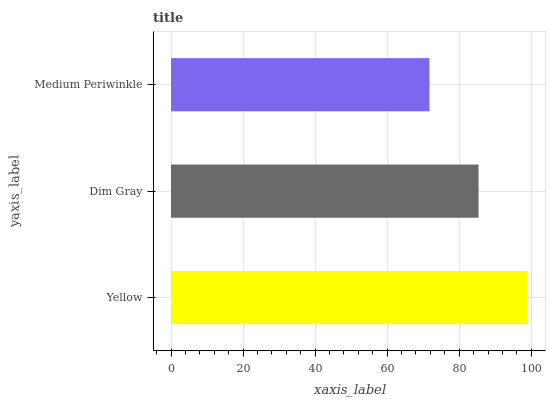Is Medium Periwinkle the minimum?
Answer yes or no. Yes. Is Yellow the maximum?
Answer yes or no. Yes. Is Dim Gray the minimum?
Answer yes or no. No. Is Dim Gray the maximum?
Answer yes or no. No. Is Yellow greater than Dim Gray?
Answer yes or no. Yes. Is Dim Gray less than Yellow?
Answer yes or no. Yes. Is Dim Gray greater than Yellow?
Answer yes or no. No. Is Yellow less than Dim Gray?
Answer yes or no. No. Is Dim Gray the high median?
Answer yes or no. Yes. Is Dim Gray the low median?
Answer yes or no. Yes. Is Medium Periwinkle the high median?
Answer yes or no. No. Is Yellow the low median?
Answer yes or no. No. 